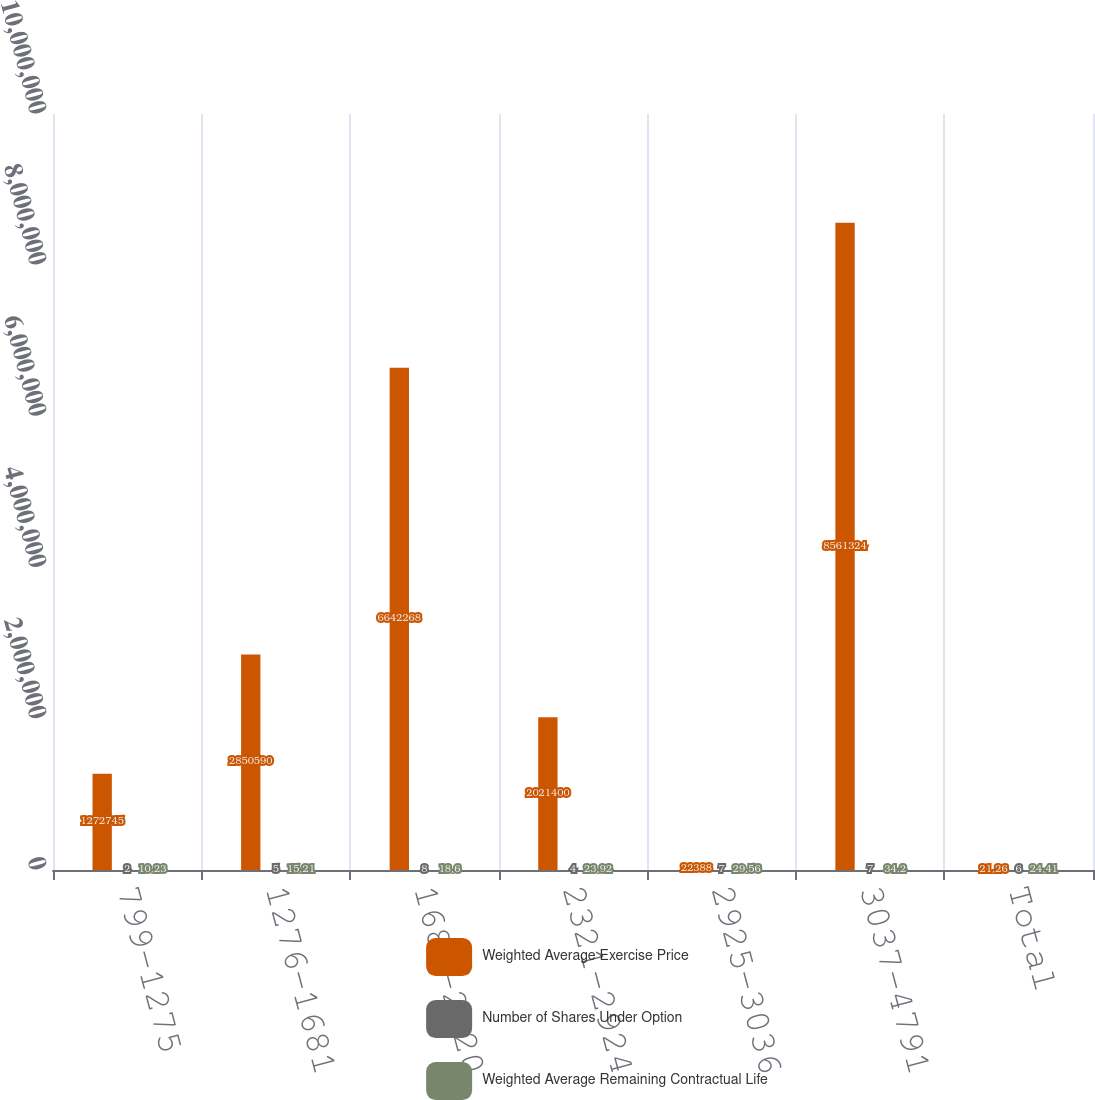<chart> <loc_0><loc_0><loc_500><loc_500><stacked_bar_chart><ecel><fcel>799-1275<fcel>1276-1681<fcel>1682-2320<fcel>2321-2924<fcel>2925-3036<fcel>3037-4791<fcel>Total<nl><fcel>Weighted Average Exercise Price<fcel>1.27274e+06<fcel>2.85059e+06<fcel>6.64227e+06<fcel>2.0214e+06<fcel>22388<fcel>8.56132e+06<fcel>21.26<nl><fcel>Number of Shares Under Option<fcel>2<fcel>5<fcel>8<fcel>4<fcel>7<fcel>7<fcel>6<nl><fcel>Weighted Average Remaining Contractual Life<fcel>10.23<fcel>15.21<fcel>18.6<fcel>23.92<fcel>29.56<fcel>34.2<fcel>24.41<nl></chart> 